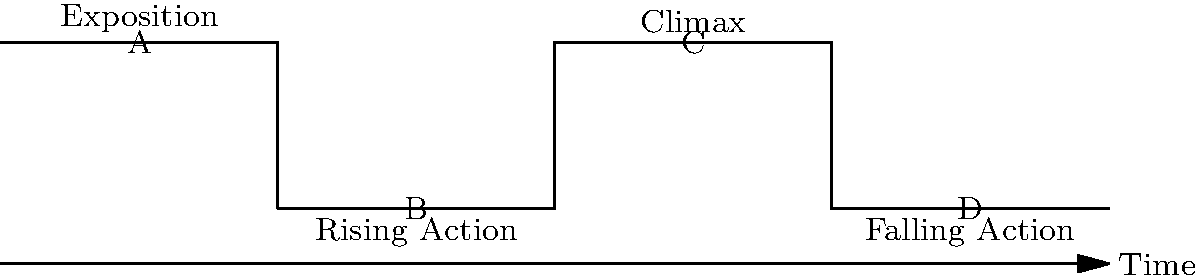In this sequential image depicting the plot progression of a Shakespearean tragedy, which letter represents the moment when the protagonist makes their fatal decision, leading to the play's dramatic turning point? To answer this question, we need to understand the structure of a typical Shakespearean tragedy:

1. The image shows four stages of plot progression: Exposition, Rising Action, Climax, and Falling Action.

2. In a Shakespearean tragedy:
   a) Exposition introduces the characters and setting.
   b) Rising Action builds tension and conflict.
   c) Climax is the turning point where the protagonist makes a crucial decision.
   d) Falling Action shows the consequences of that decision.

3. The fatal decision of the protagonist is typically the moment that leads to their downfall, which occurs at the Climax of the play.

4. In the image, the Climax is represented by the third peak, labeled with the letter C.

Therefore, the letter that represents the moment when the protagonist makes their fatal decision, leading to the play's dramatic turning point, is C.
Answer: C 